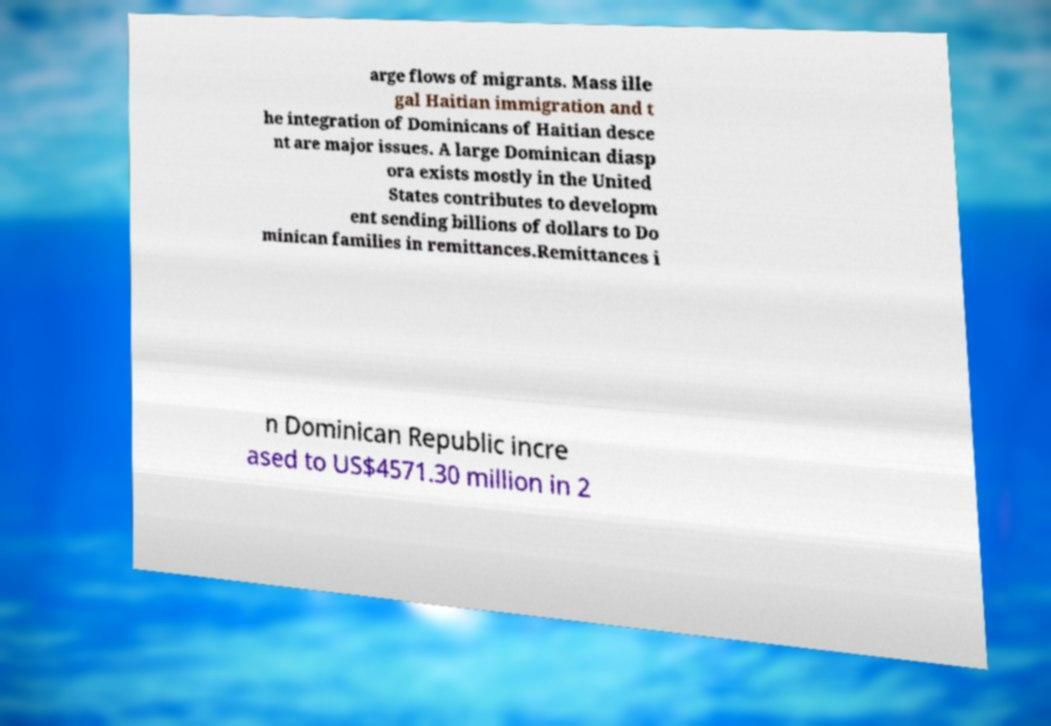For documentation purposes, I need the text within this image transcribed. Could you provide that? arge flows of migrants. Mass ille gal Haitian immigration and t he integration of Dominicans of Haitian desce nt are major issues. A large Dominican diasp ora exists mostly in the United States contributes to developm ent sending billions of dollars to Do minican families in remittances.Remittances i n Dominican Republic incre ased to US$4571.30 million in 2 